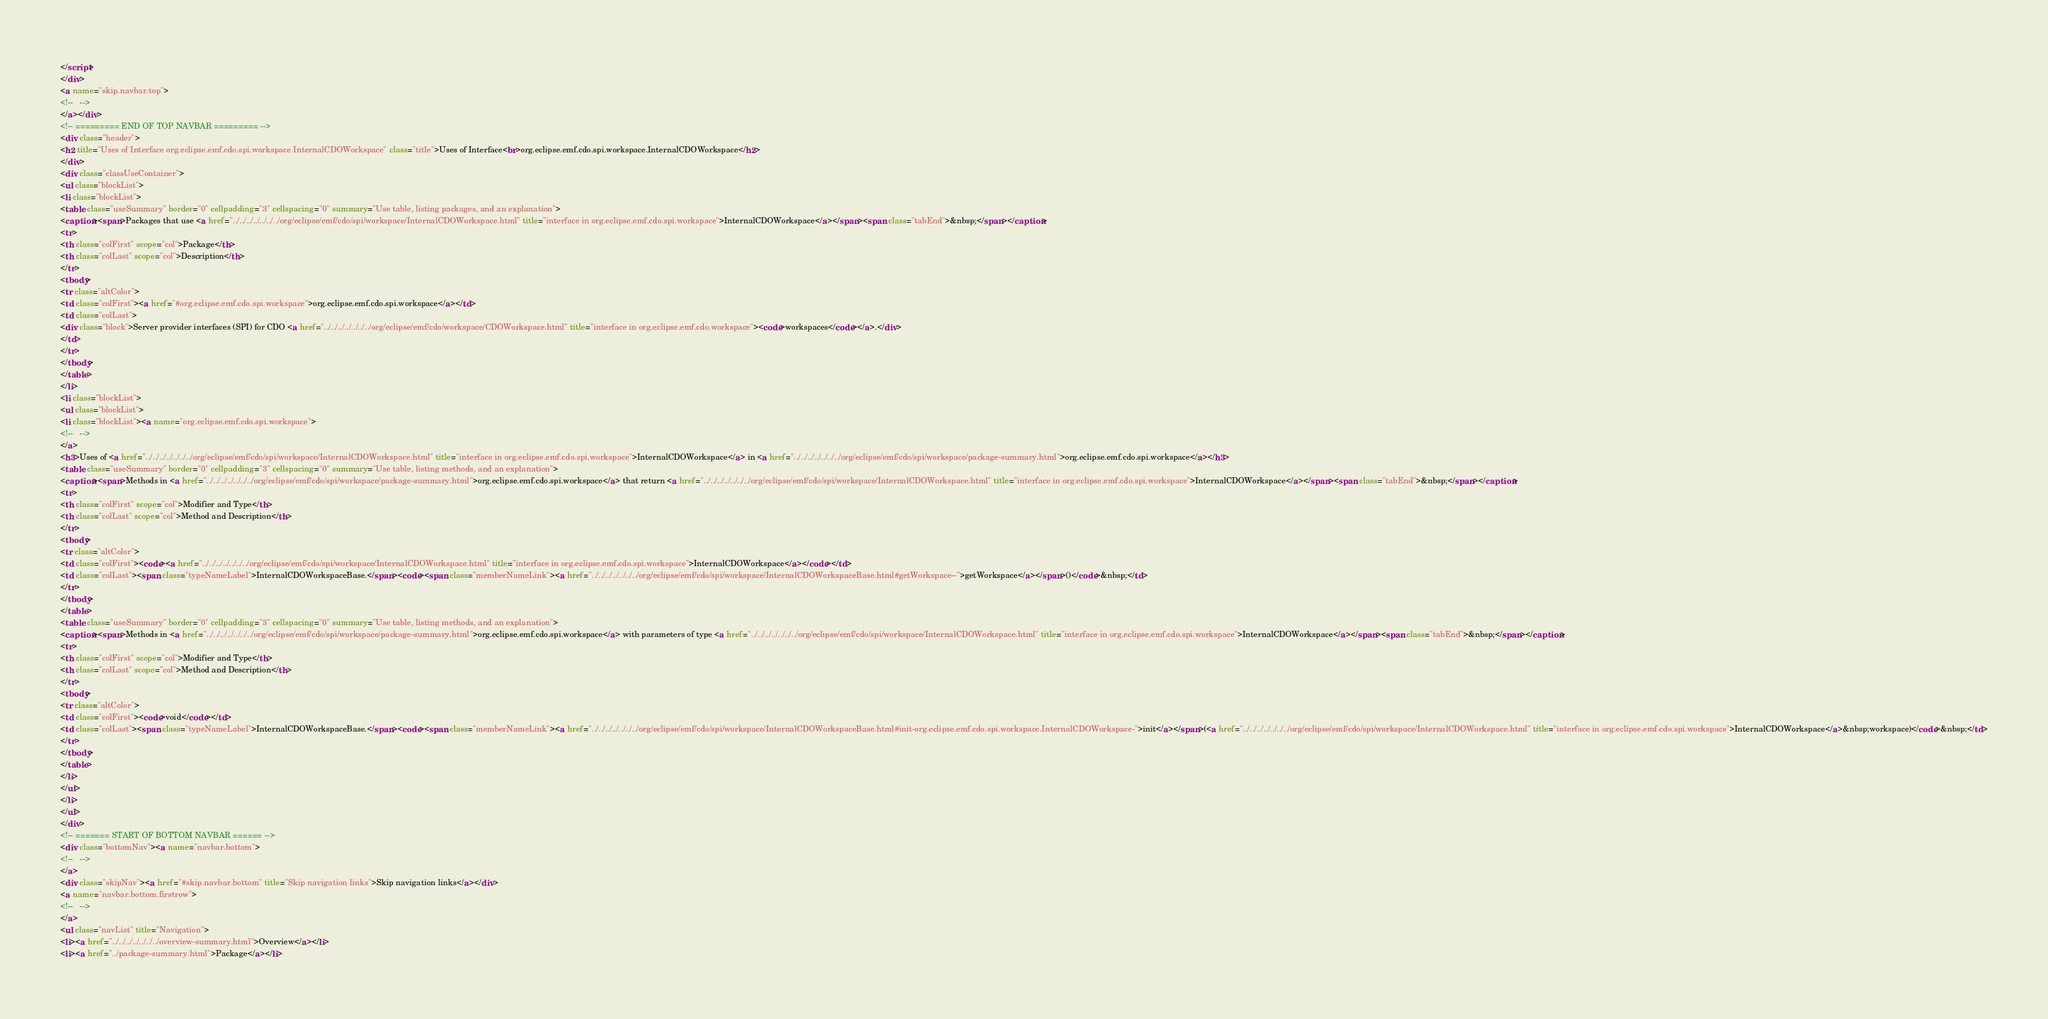<code> <loc_0><loc_0><loc_500><loc_500><_HTML_></script>
</div>
<a name="skip.navbar.top">
<!--   -->
</a></div>
<!-- ========= END OF TOP NAVBAR ========= -->
<div class="header">
<h2 title="Uses of Interface org.eclipse.emf.cdo.spi.workspace.InternalCDOWorkspace" class="title">Uses of Interface<br>org.eclipse.emf.cdo.spi.workspace.InternalCDOWorkspace</h2>
</div>
<div class="classUseContainer">
<ul class="blockList">
<li class="blockList">
<table class="useSummary" border="0" cellpadding="3" cellspacing="0" summary="Use table, listing packages, and an explanation">
<caption><span>Packages that use <a href="../../../../../../../org/eclipse/emf/cdo/spi/workspace/InternalCDOWorkspace.html" title="interface in org.eclipse.emf.cdo.spi.workspace">InternalCDOWorkspace</a></span><span class="tabEnd">&nbsp;</span></caption>
<tr>
<th class="colFirst" scope="col">Package</th>
<th class="colLast" scope="col">Description</th>
</tr>
<tbody>
<tr class="altColor">
<td class="colFirst"><a href="#org.eclipse.emf.cdo.spi.workspace">org.eclipse.emf.cdo.spi.workspace</a></td>
<td class="colLast">
<div class="block">Server provider interfaces (SPI) for CDO <a href="../../../../../../../org/eclipse/emf/cdo/workspace/CDOWorkspace.html" title="interface in org.eclipse.emf.cdo.workspace"><code>workspaces</code></a>.</div>
</td>
</tr>
</tbody>
</table>
</li>
<li class="blockList">
<ul class="blockList">
<li class="blockList"><a name="org.eclipse.emf.cdo.spi.workspace">
<!--   -->
</a>
<h3>Uses of <a href="../../../../../../../org/eclipse/emf/cdo/spi/workspace/InternalCDOWorkspace.html" title="interface in org.eclipse.emf.cdo.spi.workspace">InternalCDOWorkspace</a> in <a href="../../../../../../../org/eclipse/emf/cdo/spi/workspace/package-summary.html">org.eclipse.emf.cdo.spi.workspace</a></h3>
<table class="useSummary" border="0" cellpadding="3" cellspacing="0" summary="Use table, listing methods, and an explanation">
<caption><span>Methods in <a href="../../../../../../../org/eclipse/emf/cdo/spi/workspace/package-summary.html">org.eclipse.emf.cdo.spi.workspace</a> that return <a href="../../../../../../../org/eclipse/emf/cdo/spi/workspace/InternalCDOWorkspace.html" title="interface in org.eclipse.emf.cdo.spi.workspace">InternalCDOWorkspace</a></span><span class="tabEnd">&nbsp;</span></caption>
<tr>
<th class="colFirst" scope="col">Modifier and Type</th>
<th class="colLast" scope="col">Method and Description</th>
</tr>
<tbody>
<tr class="altColor">
<td class="colFirst"><code><a href="../../../../../../../org/eclipse/emf/cdo/spi/workspace/InternalCDOWorkspace.html" title="interface in org.eclipse.emf.cdo.spi.workspace">InternalCDOWorkspace</a></code></td>
<td class="colLast"><span class="typeNameLabel">InternalCDOWorkspaceBase.</span><code><span class="memberNameLink"><a href="../../../../../../../org/eclipse/emf/cdo/spi/workspace/InternalCDOWorkspaceBase.html#getWorkspace--">getWorkspace</a></span>()</code>&nbsp;</td>
</tr>
</tbody>
</table>
<table class="useSummary" border="0" cellpadding="3" cellspacing="0" summary="Use table, listing methods, and an explanation">
<caption><span>Methods in <a href="../../../../../../../org/eclipse/emf/cdo/spi/workspace/package-summary.html">org.eclipse.emf.cdo.spi.workspace</a> with parameters of type <a href="../../../../../../../org/eclipse/emf/cdo/spi/workspace/InternalCDOWorkspace.html" title="interface in org.eclipse.emf.cdo.spi.workspace">InternalCDOWorkspace</a></span><span class="tabEnd">&nbsp;</span></caption>
<tr>
<th class="colFirst" scope="col">Modifier and Type</th>
<th class="colLast" scope="col">Method and Description</th>
</tr>
<tbody>
<tr class="altColor">
<td class="colFirst"><code>void</code></td>
<td class="colLast"><span class="typeNameLabel">InternalCDOWorkspaceBase.</span><code><span class="memberNameLink"><a href="../../../../../../../org/eclipse/emf/cdo/spi/workspace/InternalCDOWorkspaceBase.html#init-org.eclipse.emf.cdo.spi.workspace.InternalCDOWorkspace-">init</a></span>(<a href="../../../../../../../org/eclipse/emf/cdo/spi/workspace/InternalCDOWorkspace.html" title="interface in org.eclipse.emf.cdo.spi.workspace">InternalCDOWorkspace</a>&nbsp;workspace)</code>&nbsp;</td>
</tr>
</tbody>
</table>
</li>
</ul>
</li>
</ul>
</div>
<!-- ======= START OF BOTTOM NAVBAR ====== -->
<div class="bottomNav"><a name="navbar.bottom">
<!--   -->
</a>
<div class="skipNav"><a href="#skip.navbar.bottom" title="Skip navigation links">Skip navigation links</a></div>
<a name="navbar.bottom.firstrow">
<!--   -->
</a>
<ul class="navList" title="Navigation">
<li><a href="../../../../../../../overview-summary.html">Overview</a></li>
<li><a href="../package-summary.html">Package</a></li></code> 